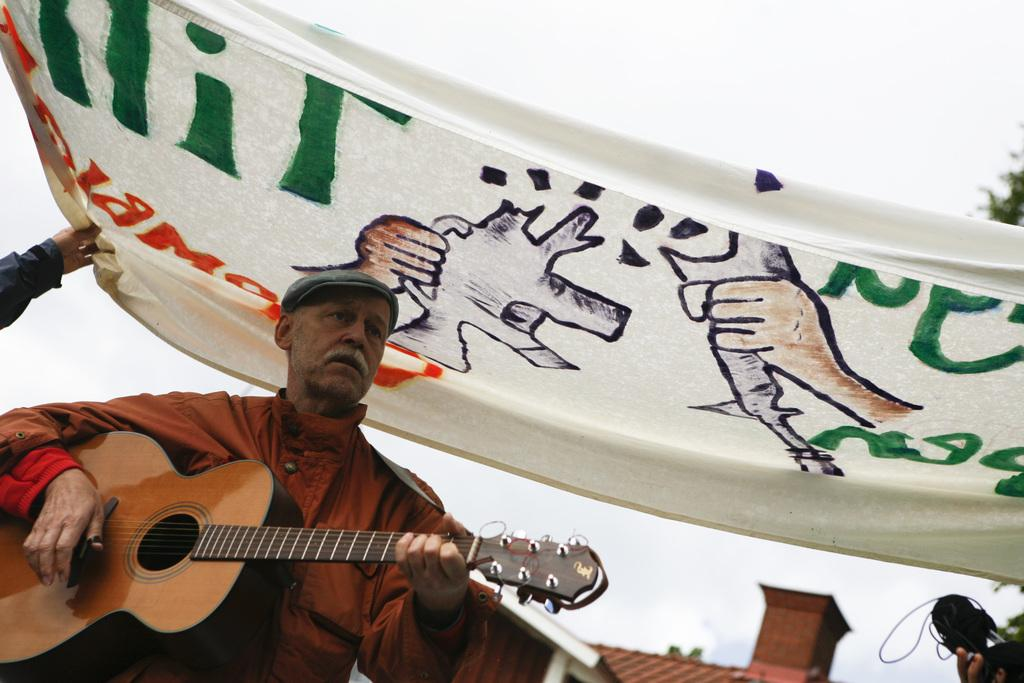What is the main subject of the image? There is a person in the image. What is the person wearing? The person is wearing a red jacket. What activity is the person engaged in? The person is playing a guitar. What can be seen in the background of the image? There is a banner in the background of the image. What type of shoe is the person wearing in the image? There is no shoe visible in the image; the person is wearing a red jacket and playing a guitar. 